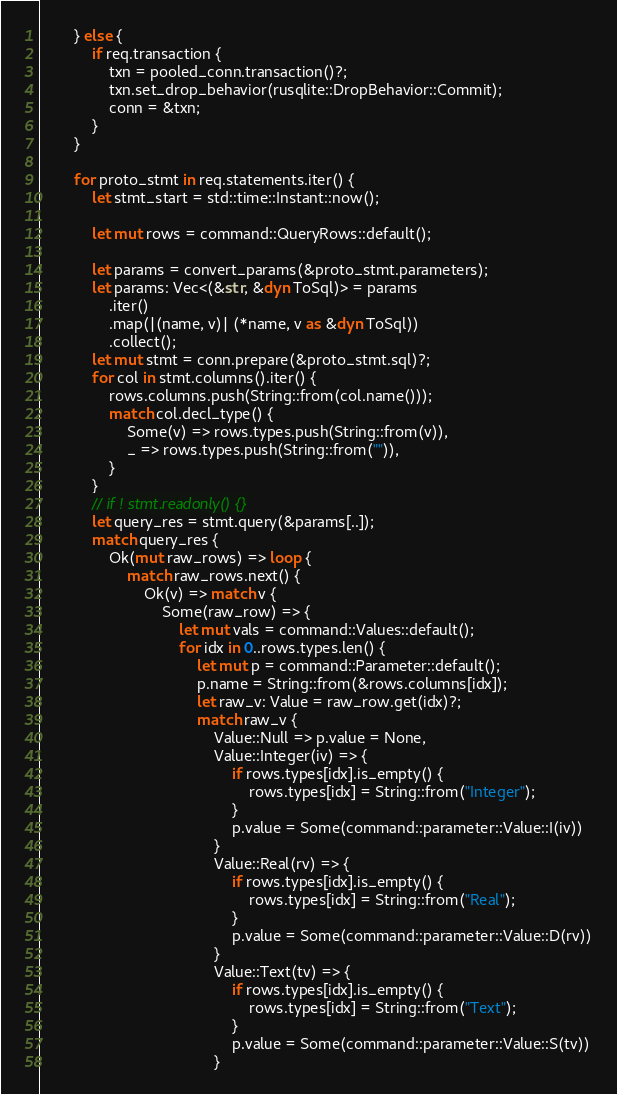Convert code to text. <code><loc_0><loc_0><loc_500><loc_500><_Rust_>        } else {
            if req.transaction {
                txn = pooled_conn.transaction()?;
                txn.set_drop_behavior(rusqlite::DropBehavior::Commit);
                conn = &txn;
            }
        }

        for proto_stmt in req.statements.iter() {
            let stmt_start = std::time::Instant::now();

            let mut rows = command::QueryRows::default();

            let params = convert_params(&proto_stmt.parameters);
            let params: Vec<(&str, &dyn ToSql)> = params
                .iter()
                .map(|(name, v)| (*name, v as &dyn ToSql))
                .collect();
            let mut stmt = conn.prepare(&proto_stmt.sql)?;
            for col in stmt.columns().iter() {
                rows.columns.push(String::from(col.name()));
                match col.decl_type() {
                    Some(v) => rows.types.push(String::from(v)),
                    _ => rows.types.push(String::from("")),
                }
            }
            // if ! stmt.readonly() {}
            let query_res = stmt.query(&params[..]);
            match query_res {
                Ok(mut raw_rows) => loop {
                    match raw_rows.next() {
                        Ok(v) => match v {
                            Some(raw_row) => {
                                let mut vals = command::Values::default();
                                for idx in 0..rows.types.len() {
                                    let mut p = command::Parameter::default();
                                    p.name = String::from(&rows.columns[idx]);
                                    let raw_v: Value = raw_row.get(idx)?;
                                    match raw_v {
                                        Value::Null => p.value = None,
                                        Value::Integer(iv) => {
                                            if rows.types[idx].is_empty() {
                                                rows.types[idx] = String::from("Integer");
                                            }
                                            p.value = Some(command::parameter::Value::I(iv))
                                        }
                                        Value::Real(rv) => {
                                            if rows.types[idx].is_empty() {
                                                rows.types[idx] = String::from("Real");
                                            }
                                            p.value = Some(command::parameter::Value::D(rv))
                                        }
                                        Value::Text(tv) => {
                                            if rows.types[idx].is_empty() {
                                                rows.types[idx] = String::from("Text");
                                            }
                                            p.value = Some(command::parameter::Value::S(tv))
                                        }</code> 